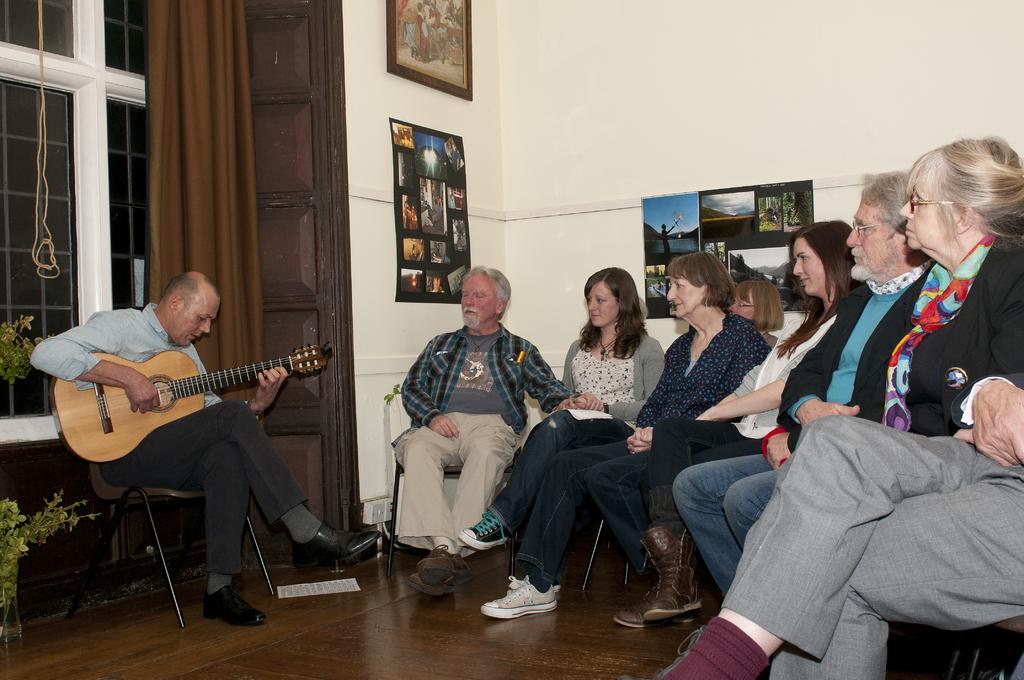How would you summarize this image in a sentence or two? A man is playing guitar while a group of people are listening to him. 